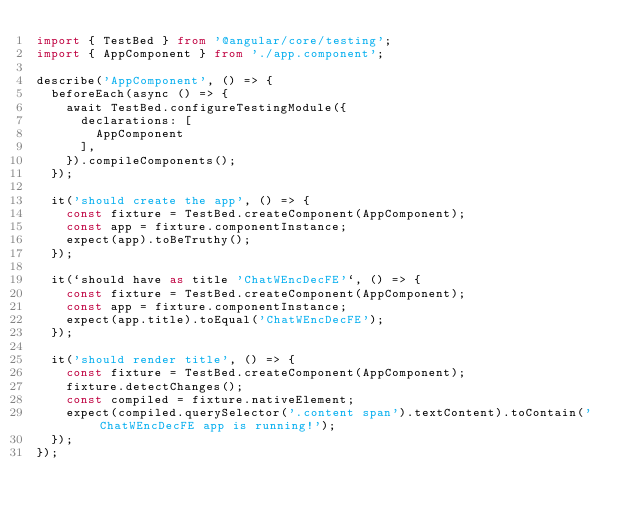Convert code to text. <code><loc_0><loc_0><loc_500><loc_500><_TypeScript_>import { TestBed } from '@angular/core/testing';
import { AppComponent } from './app.component';

describe('AppComponent', () => {
  beforeEach(async () => {
    await TestBed.configureTestingModule({
      declarations: [
        AppComponent
      ],
    }).compileComponents();
  });

  it('should create the app', () => {
    const fixture = TestBed.createComponent(AppComponent);
    const app = fixture.componentInstance;
    expect(app).toBeTruthy();
  });

  it(`should have as title 'ChatWEncDecFE'`, () => {
    const fixture = TestBed.createComponent(AppComponent);
    const app = fixture.componentInstance;
    expect(app.title).toEqual('ChatWEncDecFE');
  });

  it('should render title', () => {
    const fixture = TestBed.createComponent(AppComponent);
    fixture.detectChanges();
    const compiled = fixture.nativeElement;
    expect(compiled.querySelector('.content span').textContent).toContain('ChatWEncDecFE app is running!');
  });
});
</code> 